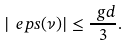Convert formula to latex. <formula><loc_0><loc_0><loc_500><loc_500>| \ e p s ( \nu ) | \leq \frac { \ g d } { 3 } .</formula> 